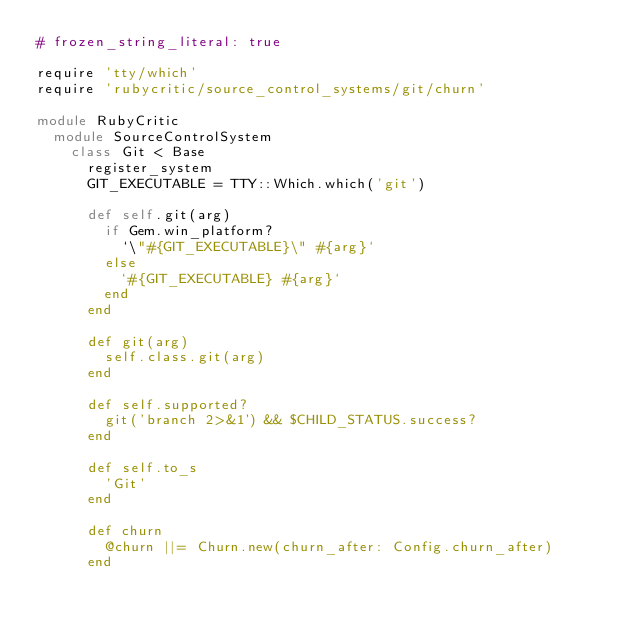<code> <loc_0><loc_0><loc_500><loc_500><_Ruby_># frozen_string_literal: true

require 'tty/which'
require 'rubycritic/source_control_systems/git/churn'

module RubyCritic
  module SourceControlSystem
    class Git < Base
      register_system
      GIT_EXECUTABLE = TTY::Which.which('git')

      def self.git(arg)
        if Gem.win_platform?
          `\"#{GIT_EXECUTABLE}\" #{arg}`
        else
          `#{GIT_EXECUTABLE} #{arg}`
        end
      end

      def git(arg)
        self.class.git(arg)
      end

      def self.supported?
        git('branch 2>&1') && $CHILD_STATUS.success?
      end

      def self.to_s
        'Git'
      end

      def churn
        @churn ||= Churn.new(churn_after: Config.churn_after)
      end
</code> 